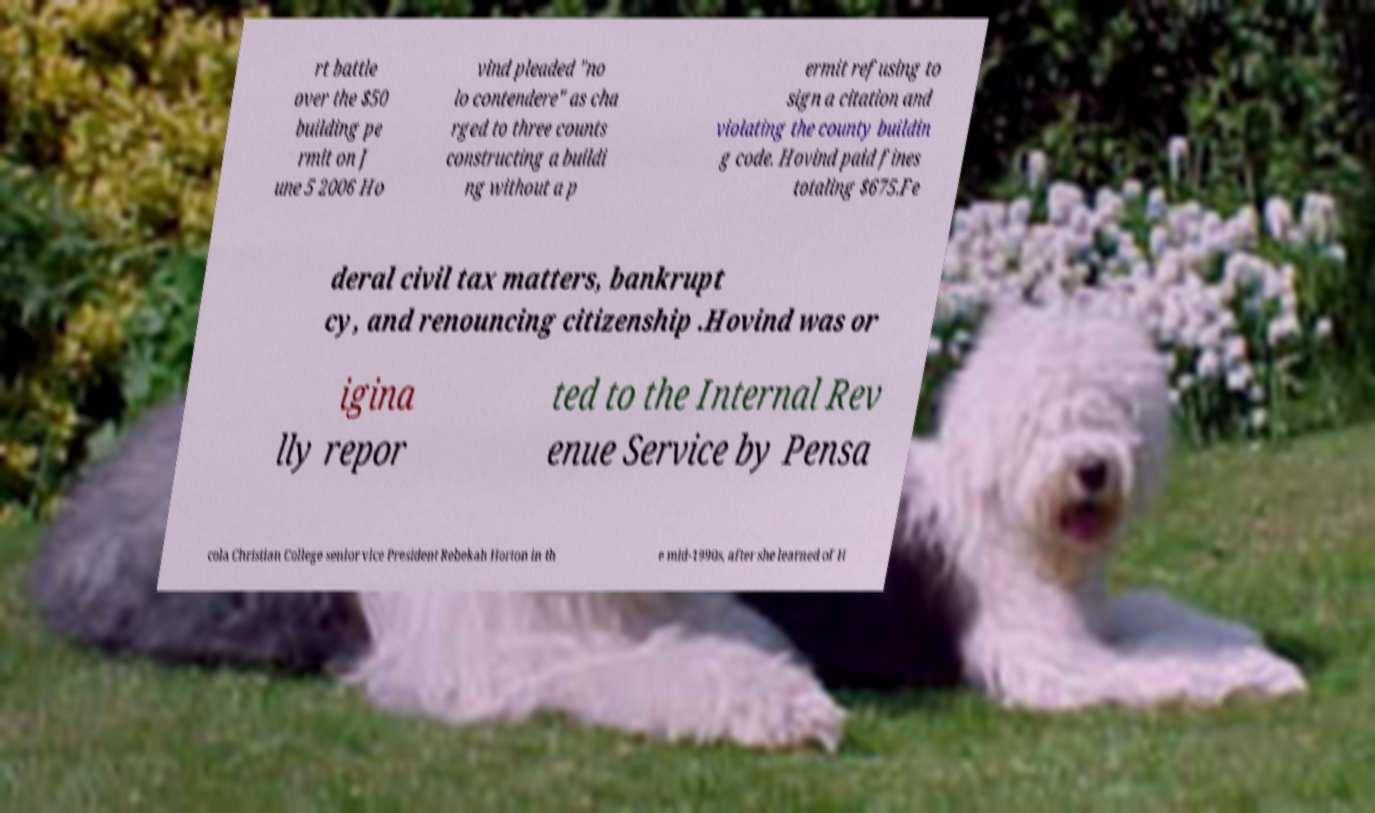Can you read and provide the text displayed in the image?This photo seems to have some interesting text. Can you extract and type it out for me? rt battle over the $50 building pe rmit on J une 5 2006 Ho vind pleaded "no lo contendere" as cha rged to three counts constructing a buildi ng without a p ermit refusing to sign a citation and violating the county buildin g code. Hovind paid fines totaling $675.Fe deral civil tax matters, bankrupt cy, and renouncing citizenship .Hovind was or igina lly repor ted to the Internal Rev enue Service by Pensa cola Christian College senior vice President Rebekah Horton in th e mid-1990s, after she learned of H 